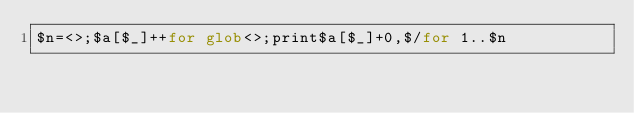Convert code to text. <code><loc_0><loc_0><loc_500><loc_500><_Perl_>$n=<>;$a[$_]++for glob<>;print$a[$_]+0,$/for 1..$n</code> 